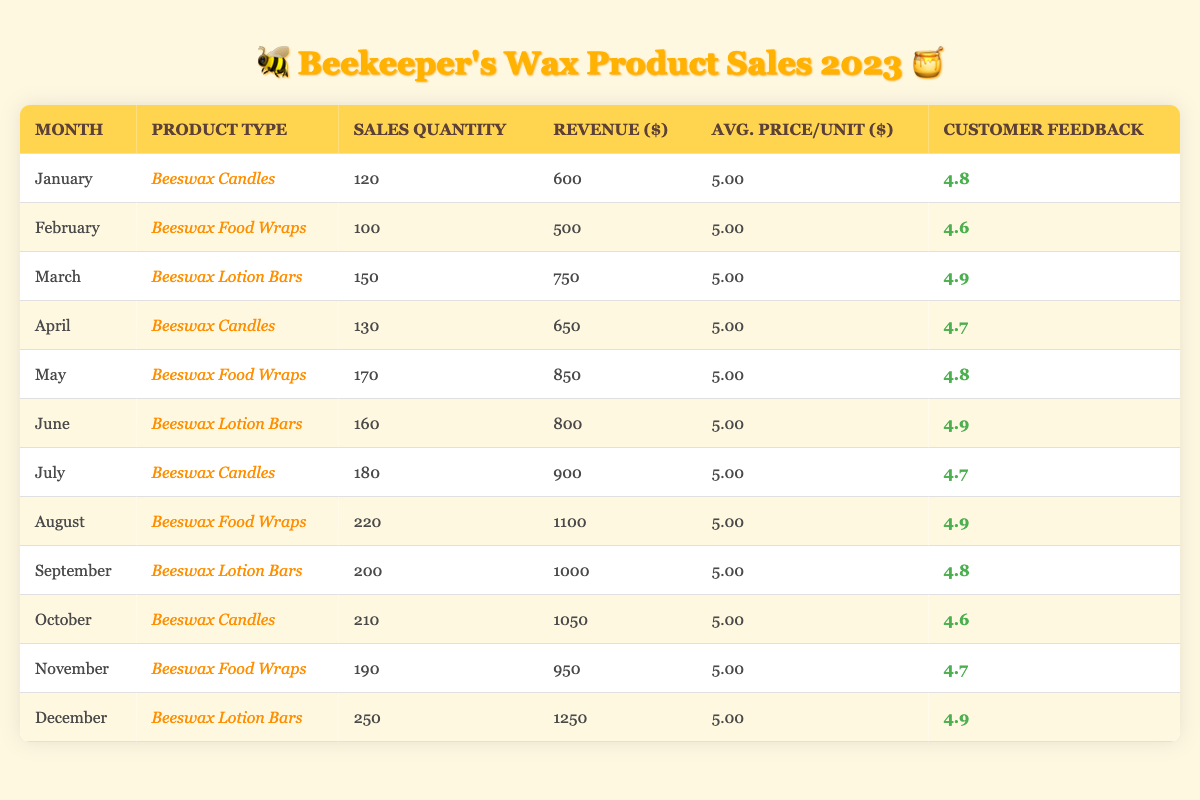What was the total revenue generated from Beeswax Candles in 2023? To find the total revenue from Beeswax Candles, we look at the sales data for each month where Beeswax Candles are sold: January ($600), April ($650), July ($900), and October ($1050). Summing these amounts gives us $600 + $650 + $900 + $1050 = $3200.
Answer: 3200 What was the average Customer Feedback Score for Beeswax Lotion Bars in 2023? The Customer Feedback Scores for Beeswax Lotion Bars occur in March (4.9), June (4.9), September (4.8), and December (4.9). To find the average, we add these scores: 4.9 + 4.9 + 4.8 + 4.9 = 19.5 and divide by 4, resulting in an average score of 19.5 / 4 = 4.875.
Answer: 4.875 Did the sales quantity for Beeswax Food Wraps peak in August? The sales quantities for Beeswax Food Wraps are 100 in February, 170 in May, and 220 in August. Since 220 is the highest figure recorded, it confirms that the peak sales quantity occurred in August.
Answer: Yes Which type of wax product had the highest sales quantity in December? In December, the sales quantity was 250 for Beeswax Lotion Bars, while the other products had lower quantities in their respective months (e.g., 190 for Beeswax Food Wraps). Thus, Beeswax Lotion Bars had the highest sales quantity in December.
Answer: Beeswax Lotion Bars What was the total sales quantity for all wax products sold in the first half of 2023? In the first half of the year (January to June), the sales quantities are: January (120), February (100), March (150), April (130), May (170), and June (160). We sum these quantities: 120 + 100 + 150 + 130 + 170 + 160 = 930, giving us the total sales for the first half.
Answer: 930 Was the average price per unit for all wax products consistent throughout 2023? The average price per unit for all wax products listed throughout 2023 is consistently $5.00 for each product type in every month, indicating no variation.
Answer: Yes How much revenue was generated from Beeswax Food Wraps between May and November? The revenue for Beeswax Food Wraps from May (850), August (1100), and November (950) can be calculated to find the total for this period: 850 + 1100 + 950 = 2900, thus illustrating the revenue generated in that timeframe.
Answer: 2900 What was the maximum Customer Feedback Score recorded in 2023? The Customer Feedback Scores across all months range from 4.6 to 4.9. The highest score is 4.9, given in March, June, September, and December, making this the maximum recorded in 2023.
Answer: 4.9 